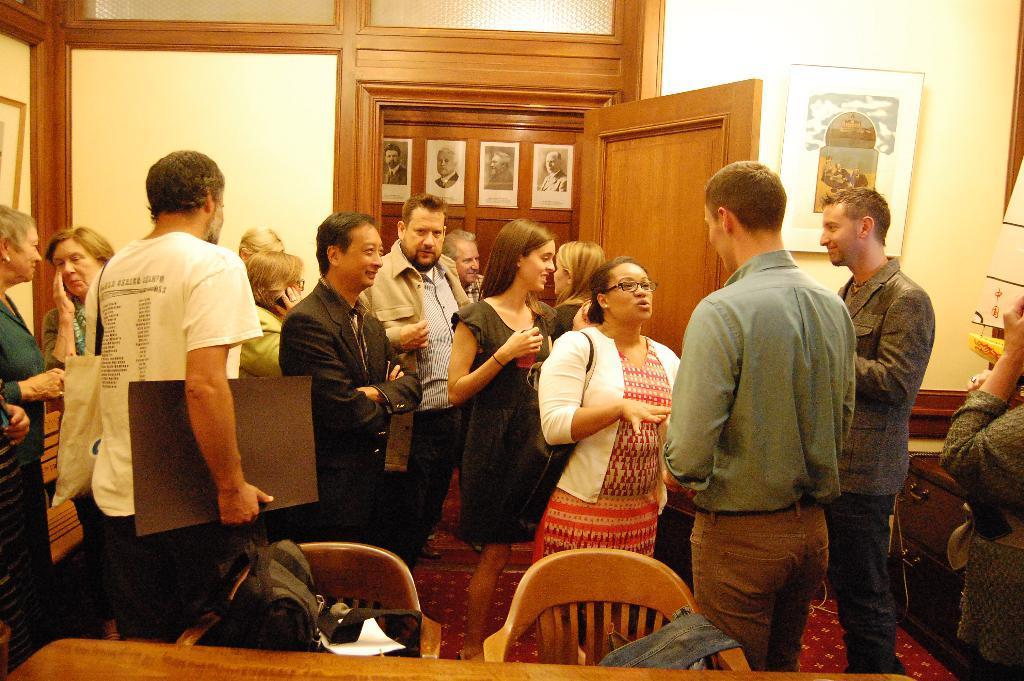Can you describe this image briefly? There are group of people standing. Among them few people are talking to each other. These are the frames, which are attached to the wall. This looks like a wooden table. There are two chairs. I think these are the drawers. This is a wooden door. I can see a bag, which is placed in the chair. On the right side of the image, I can see another person standing. This is a carpet on the floor. 